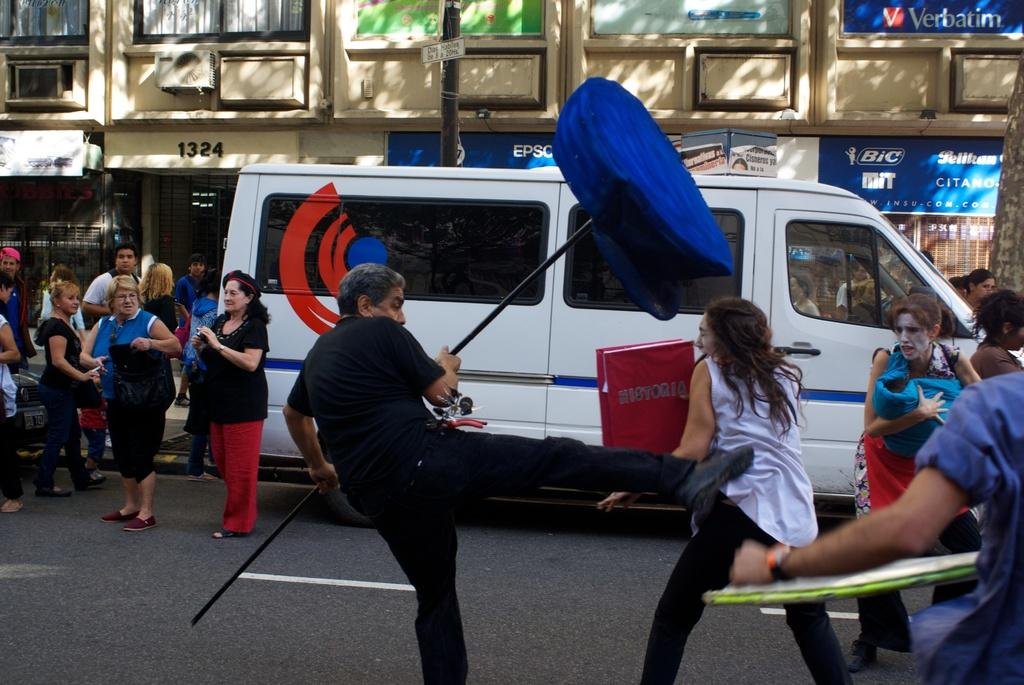<image>
Present a compact description of the photo's key features. a Bic sign in the back of a tv commercial being filmed 